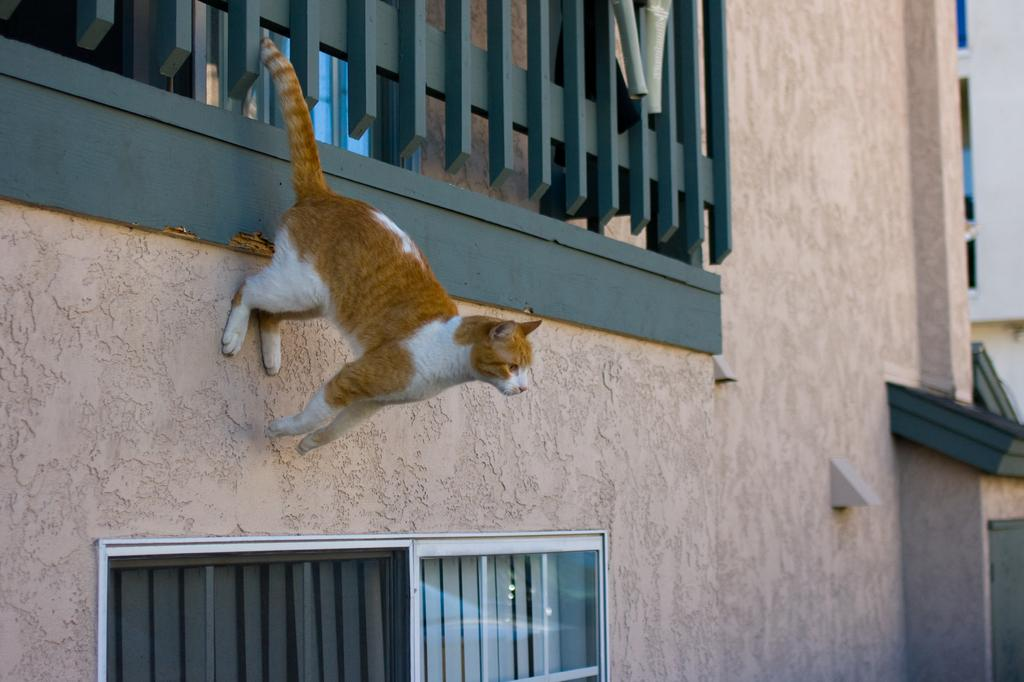What type of animal is in the image? There is a brown and white color cat in the image. Where is the cat located? The cat is on a building's wall. What else can be seen in the image besides the cat? There are windows visible in the image. What type of bag is the cat holding in the image? There is no bag present in the image; the cat is simply sitting on the building's wall. 